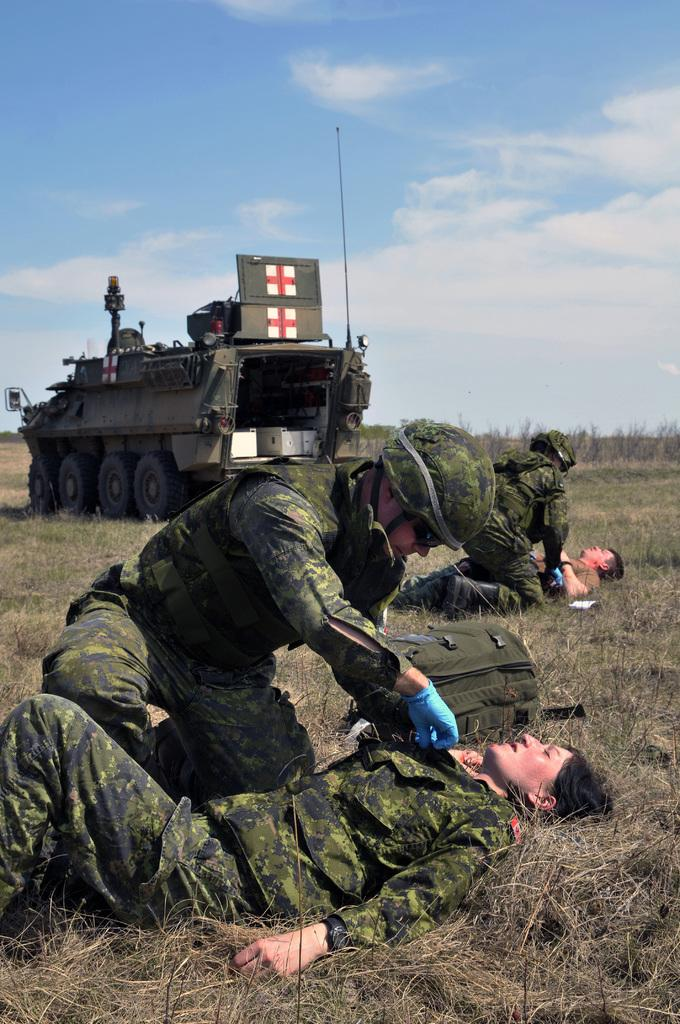How many people are present in the image? There are four persons in the image. What are two of the persons doing in the image? Two of the persons are lying on the ground. What can be seen in the background of the image? There is a vehicle and the sky visible in the background of the image. Is the ground made of quicksand in the image? There is no indication in the image that the ground is made of quicksand. How many light bulbs can be seen in the image? There are no light bulbs present in the image. 